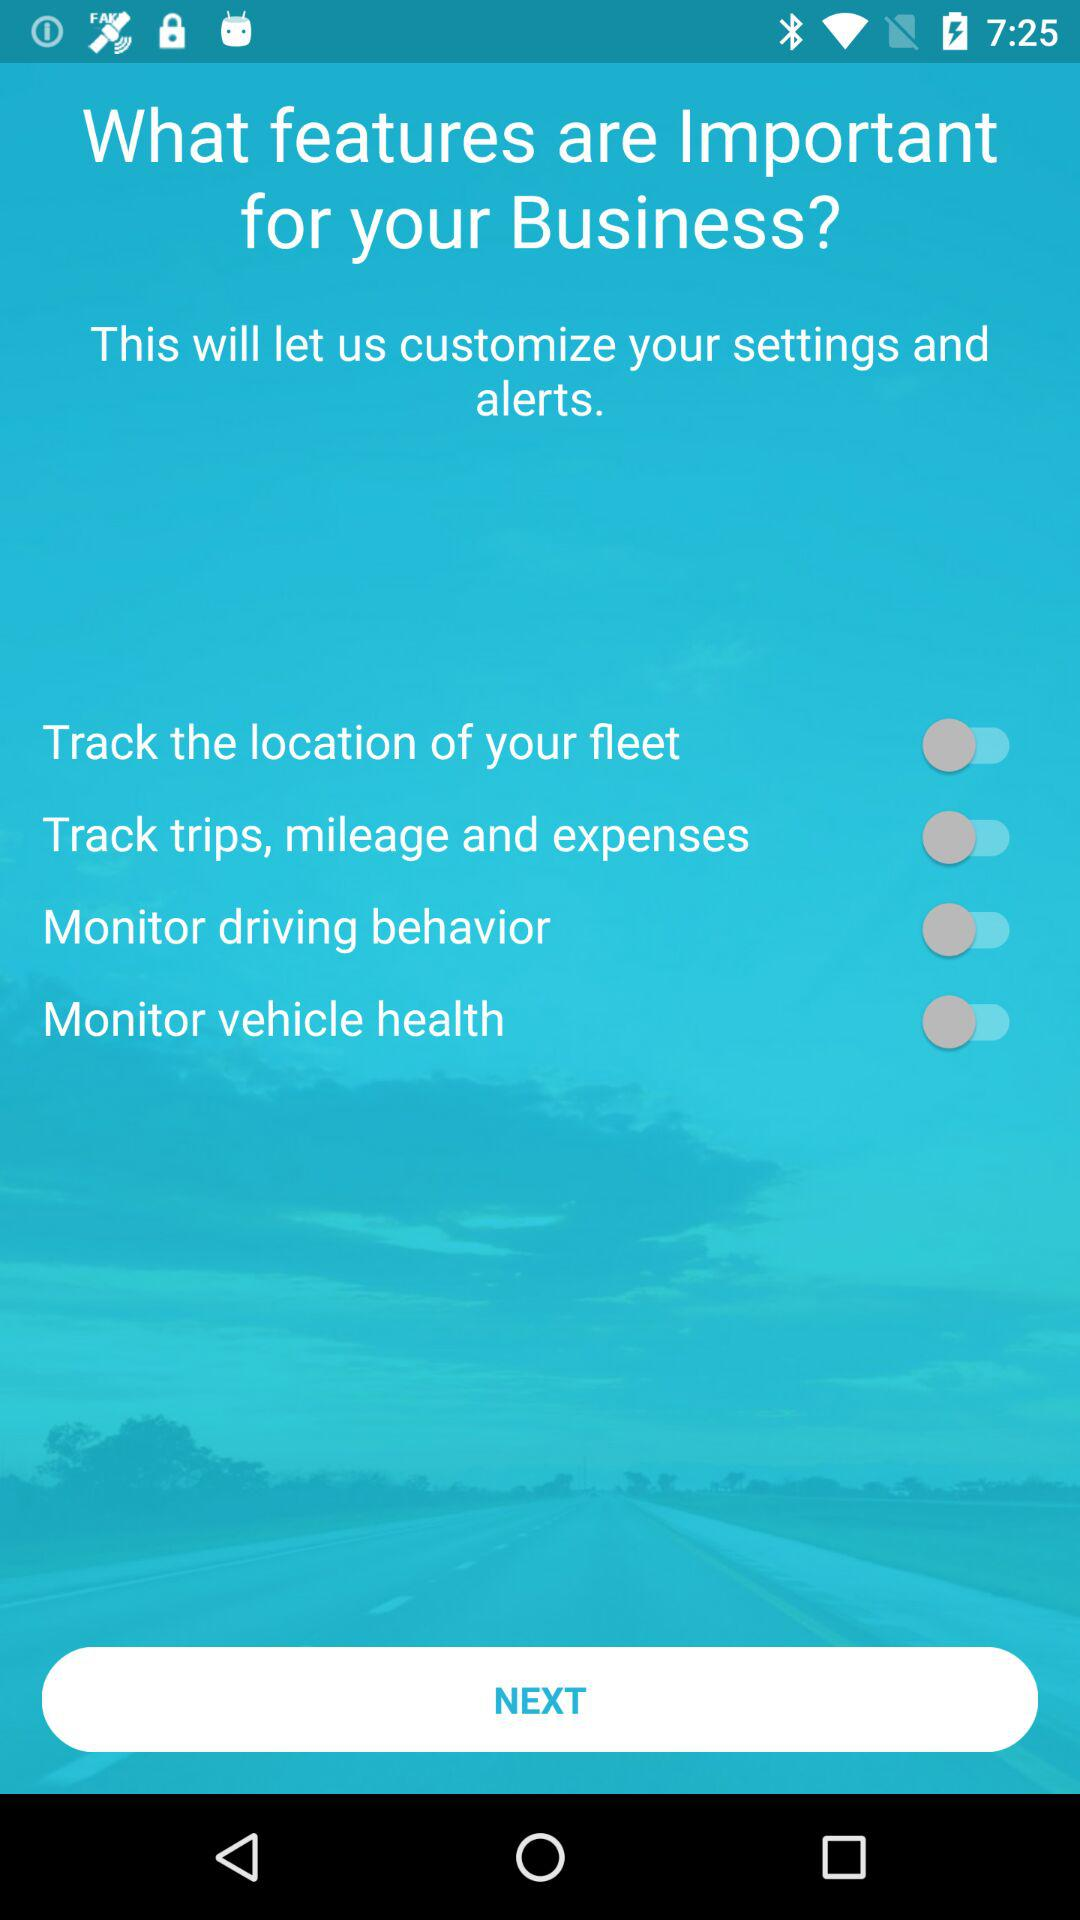How many features are there on the screen?
Answer the question using a single word or phrase. 4 